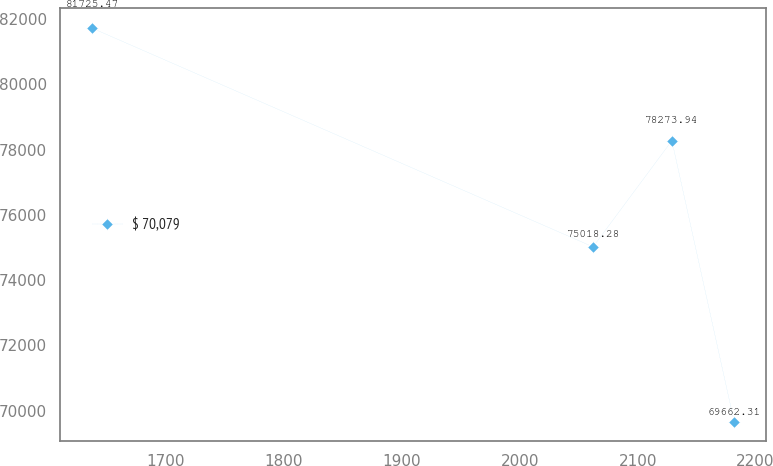Convert chart to OTSL. <chart><loc_0><loc_0><loc_500><loc_500><line_chart><ecel><fcel>$ 70,079<nl><fcel>1637.43<fcel>81725.5<nl><fcel>2062.2<fcel>75018.3<nl><fcel>2129.03<fcel>78273.9<nl><fcel>2181.78<fcel>69662.3<nl></chart> 